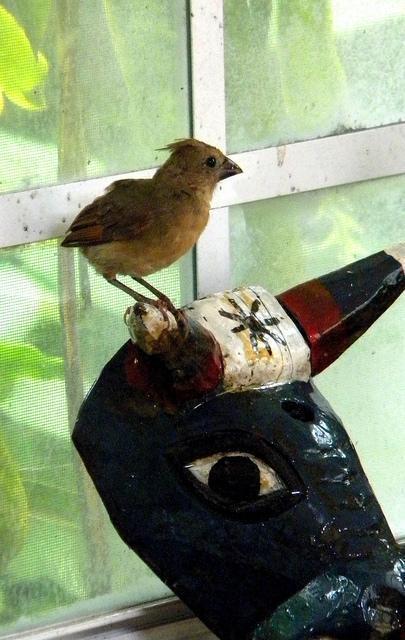How many birds are in the picture?
Give a very brief answer. 1. 